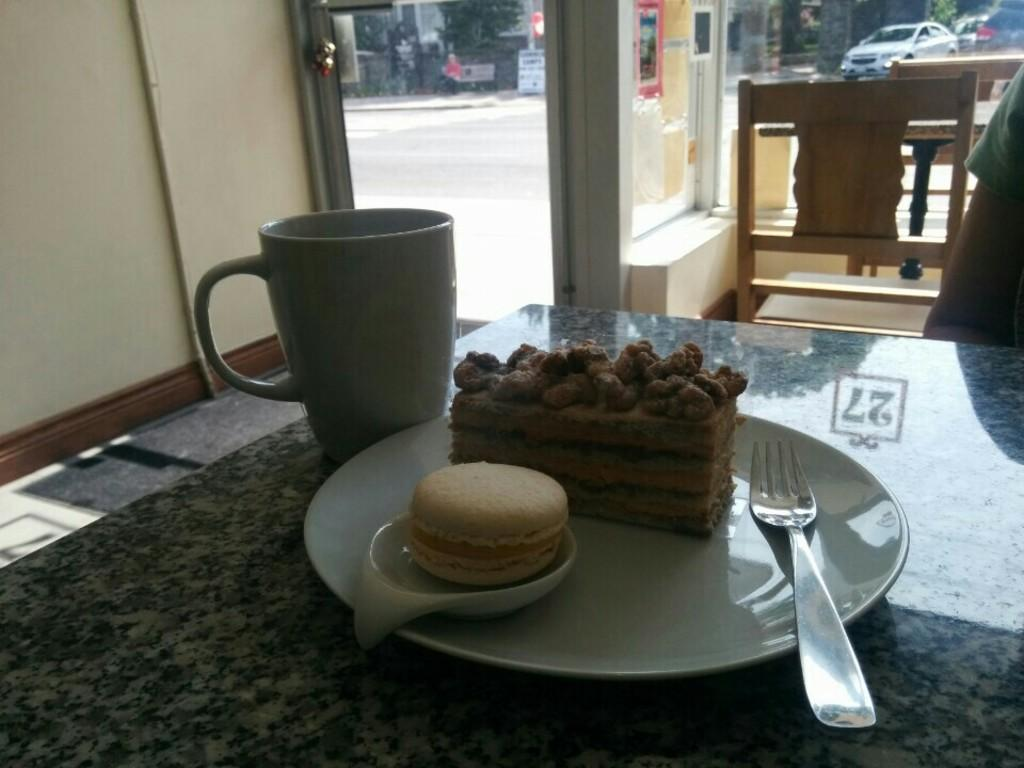What piece of furniture is present in the image? There is a table in the image. What is placed on the table? There is a plate and a jug on the table. What type of seating is visible in the image? There is a chair in the image. Who or what is in front of the table? There is a person in front of the table. What type of credit card is the person using to pay for the meal in the image? There is no credit card or payment transaction depicted in the image. How many light bulbs are visible in the image? There are no light bulbs present in the image. 